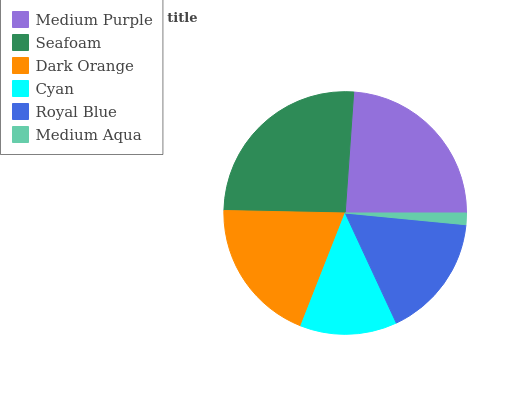Is Medium Aqua the minimum?
Answer yes or no. Yes. Is Seafoam the maximum?
Answer yes or no. Yes. Is Dark Orange the minimum?
Answer yes or no. No. Is Dark Orange the maximum?
Answer yes or no. No. Is Seafoam greater than Dark Orange?
Answer yes or no. Yes. Is Dark Orange less than Seafoam?
Answer yes or no. Yes. Is Dark Orange greater than Seafoam?
Answer yes or no. No. Is Seafoam less than Dark Orange?
Answer yes or no. No. Is Dark Orange the high median?
Answer yes or no. Yes. Is Royal Blue the low median?
Answer yes or no. Yes. Is Seafoam the high median?
Answer yes or no. No. Is Dark Orange the low median?
Answer yes or no. No. 